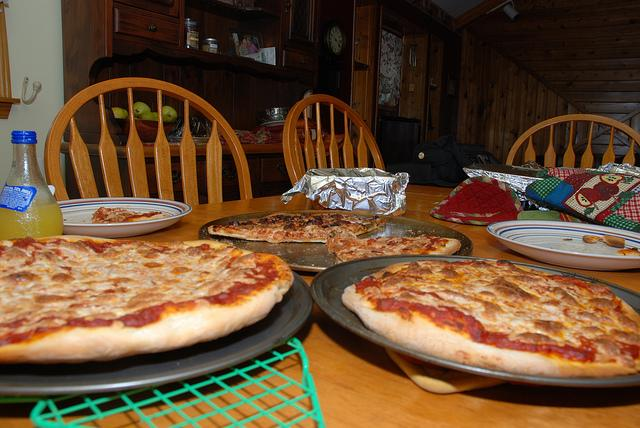The glass drink on the table has what as its primary flavor?

Choices:
A) citrus
B) tea
C) cola
D) pineapple citrus 